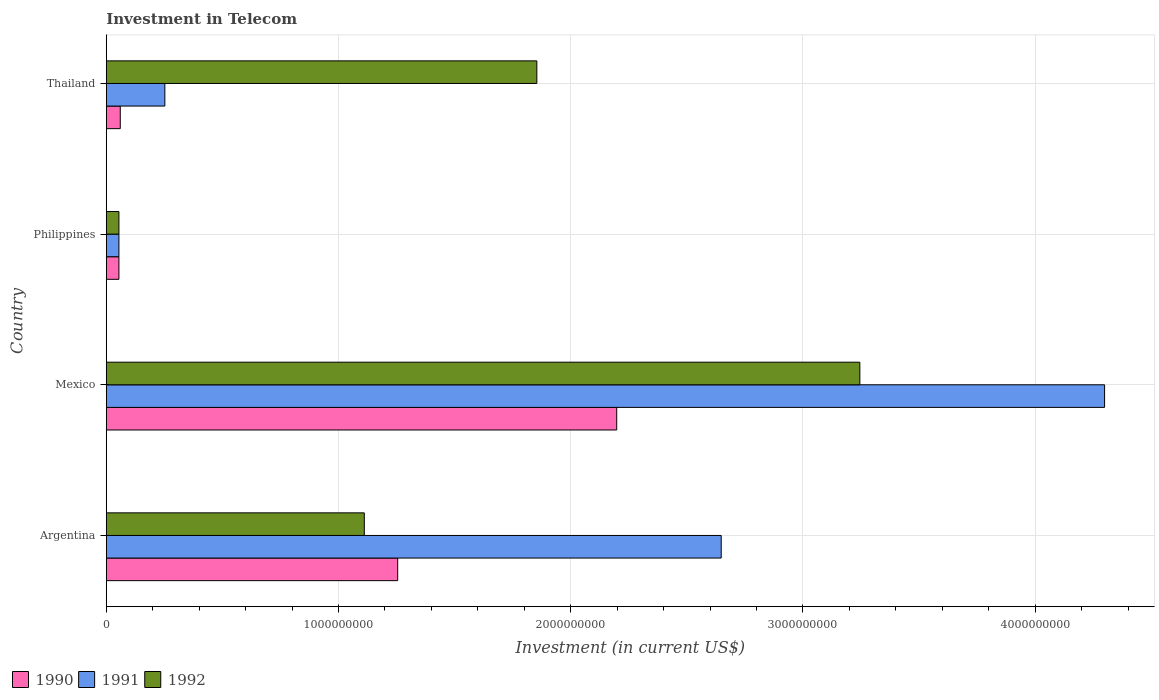How many groups of bars are there?
Provide a short and direct response. 4. How many bars are there on the 2nd tick from the bottom?
Offer a very short reply. 3. What is the amount invested in telecom in 1991 in Mexico?
Keep it short and to the point. 4.30e+09. Across all countries, what is the maximum amount invested in telecom in 1992?
Keep it short and to the point. 3.24e+09. Across all countries, what is the minimum amount invested in telecom in 1991?
Offer a very short reply. 5.42e+07. In which country was the amount invested in telecom in 1990 maximum?
Offer a very short reply. Mexico. What is the total amount invested in telecom in 1990 in the graph?
Provide a succinct answer. 3.57e+09. What is the difference between the amount invested in telecom in 1990 in Mexico and that in Philippines?
Ensure brevity in your answer.  2.14e+09. What is the difference between the amount invested in telecom in 1991 in Philippines and the amount invested in telecom in 1990 in Mexico?
Make the answer very short. -2.14e+09. What is the average amount invested in telecom in 1992 per country?
Keep it short and to the point. 1.57e+09. What is the difference between the amount invested in telecom in 1991 and amount invested in telecom in 1990 in Philippines?
Provide a succinct answer. 0. In how many countries, is the amount invested in telecom in 1992 greater than 800000000 US$?
Provide a succinct answer. 3. What is the ratio of the amount invested in telecom in 1991 in Argentina to that in Thailand?
Keep it short and to the point. 10.51. What is the difference between the highest and the second highest amount invested in telecom in 1991?
Your answer should be very brief. 1.65e+09. What is the difference between the highest and the lowest amount invested in telecom in 1991?
Your answer should be very brief. 4.24e+09. Is the sum of the amount invested in telecom in 1991 in Argentina and Mexico greater than the maximum amount invested in telecom in 1990 across all countries?
Offer a terse response. Yes. What does the 3rd bar from the bottom in Philippines represents?
Your answer should be very brief. 1992. Are all the bars in the graph horizontal?
Give a very brief answer. Yes. How many countries are there in the graph?
Your answer should be compact. 4. What is the difference between two consecutive major ticks on the X-axis?
Provide a short and direct response. 1.00e+09. Does the graph contain grids?
Your answer should be very brief. Yes. Where does the legend appear in the graph?
Provide a short and direct response. Bottom left. How many legend labels are there?
Keep it short and to the point. 3. How are the legend labels stacked?
Offer a terse response. Horizontal. What is the title of the graph?
Give a very brief answer. Investment in Telecom. Does "1974" appear as one of the legend labels in the graph?
Provide a succinct answer. No. What is the label or title of the X-axis?
Your answer should be very brief. Investment (in current US$). What is the label or title of the Y-axis?
Your answer should be very brief. Country. What is the Investment (in current US$) of 1990 in Argentina?
Make the answer very short. 1.25e+09. What is the Investment (in current US$) in 1991 in Argentina?
Make the answer very short. 2.65e+09. What is the Investment (in current US$) of 1992 in Argentina?
Offer a terse response. 1.11e+09. What is the Investment (in current US$) in 1990 in Mexico?
Give a very brief answer. 2.20e+09. What is the Investment (in current US$) of 1991 in Mexico?
Your answer should be compact. 4.30e+09. What is the Investment (in current US$) in 1992 in Mexico?
Ensure brevity in your answer.  3.24e+09. What is the Investment (in current US$) in 1990 in Philippines?
Offer a very short reply. 5.42e+07. What is the Investment (in current US$) in 1991 in Philippines?
Offer a terse response. 5.42e+07. What is the Investment (in current US$) of 1992 in Philippines?
Offer a terse response. 5.42e+07. What is the Investment (in current US$) of 1990 in Thailand?
Keep it short and to the point. 6.00e+07. What is the Investment (in current US$) of 1991 in Thailand?
Provide a succinct answer. 2.52e+08. What is the Investment (in current US$) of 1992 in Thailand?
Keep it short and to the point. 1.85e+09. Across all countries, what is the maximum Investment (in current US$) of 1990?
Your answer should be very brief. 2.20e+09. Across all countries, what is the maximum Investment (in current US$) of 1991?
Your response must be concise. 4.30e+09. Across all countries, what is the maximum Investment (in current US$) in 1992?
Your response must be concise. 3.24e+09. Across all countries, what is the minimum Investment (in current US$) in 1990?
Keep it short and to the point. 5.42e+07. Across all countries, what is the minimum Investment (in current US$) of 1991?
Keep it short and to the point. 5.42e+07. Across all countries, what is the minimum Investment (in current US$) of 1992?
Your answer should be compact. 5.42e+07. What is the total Investment (in current US$) of 1990 in the graph?
Give a very brief answer. 3.57e+09. What is the total Investment (in current US$) of 1991 in the graph?
Ensure brevity in your answer.  7.25e+09. What is the total Investment (in current US$) of 1992 in the graph?
Your response must be concise. 6.26e+09. What is the difference between the Investment (in current US$) in 1990 in Argentina and that in Mexico?
Make the answer very short. -9.43e+08. What is the difference between the Investment (in current US$) in 1991 in Argentina and that in Mexico?
Keep it short and to the point. -1.65e+09. What is the difference between the Investment (in current US$) of 1992 in Argentina and that in Mexico?
Provide a succinct answer. -2.13e+09. What is the difference between the Investment (in current US$) in 1990 in Argentina and that in Philippines?
Keep it short and to the point. 1.20e+09. What is the difference between the Investment (in current US$) in 1991 in Argentina and that in Philippines?
Your response must be concise. 2.59e+09. What is the difference between the Investment (in current US$) in 1992 in Argentina and that in Philippines?
Provide a succinct answer. 1.06e+09. What is the difference between the Investment (in current US$) of 1990 in Argentina and that in Thailand?
Provide a succinct answer. 1.19e+09. What is the difference between the Investment (in current US$) of 1991 in Argentina and that in Thailand?
Provide a short and direct response. 2.40e+09. What is the difference between the Investment (in current US$) of 1992 in Argentina and that in Thailand?
Keep it short and to the point. -7.43e+08. What is the difference between the Investment (in current US$) of 1990 in Mexico and that in Philippines?
Your response must be concise. 2.14e+09. What is the difference between the Investment (in current US$) in 1991 in Mexico and that in Philippines?
Make the answer very short. 4.24e+09. What is the difference between the Investment (in current US$) of 1992 in Mexico and that in Philippines?
Your answer should be very brief. 3.19e+09. What is the difference between the Investment (in current US$) of 1990 in Mexico and that in Thailand?
Provide a short and direct response. 2.14e+09. What is the difference between the Investment (in current US$) of 1991 in Mexico and that in Thailand?
Give a very brief answer. 4.05e+09. What is the difference between the Investment (in current US$) in 1992 in Mexico and that in Thailand?
Your response must be concise. 1.39e+09. What is the difference between the Investment (in current US$) of 1990 in Philippines and that in Thailand?
Make the answer very short. -5.80e+06. What is the difference between the Investment (in current US$) in 1991 in Philippines and that in Thailand?
Offer a very short reply. -1.98e+08. What is the difference between the Investment (in current US$) in 1992 in Philippines and that in Thailand?
Offer a very short reply. -1.80e+09. What is the difference between the Investment (in current US$) in 1990 in Argentina and the Investment (in current US$) in 1991 in Mexico?
Provide a succinct answer. -3.04e+09. What is the difference between the Investment (in current US$) in 1990 in Argentina and the Investment (in current US$) in 1992 in Mexico?
Provide a short and direct response. -1.99e+09. What is the difference between the Investment (in current US$) of 1991 in Argentina and the Investment (in current US$) of 1992 in Mexico?
Your answer should be very brief. -5.97e+08. What is the difference between the Investment (in current US$) of 1990 in Argentina and the Investment (in current US$) of 1991 in Philippines?
Your answer should be compact. 1.20e+09. What is the difference between the Investment (in current US$) in 1990 in Argentina and the Investment (in current US$) in 1992 in Philippines?
Provide a succinct answer. 1.20e+09. What is the difference between the Investment (in current US$) in 1991 in Argentina and the Investment (in current US$) in 1992 in Philippines?
Provide a succinct answer. 2.59e+09. What is the difference between the Investment (in current US$) of 1990 in Argentina and the Investment (in current US$) of 1991 in Thailand?
Ensure brevity in your answer.  1.00e+09. What is the difference between the Investment (in current US$) of 1990 in Argentina and the Investment (in current US$) of 1992 in Thailand?
Your answer should be very brief. -5.99e+08. What is the difference between the Investment (in current US$) of 1991 in Argentina and the Investment (in current US$) of 1992 in Thailand?
Your response must be concise. 7.94e+08. What is the difference between the Investment (in current US$) in 1990 in Mexico and the Investment (in current US$) in 1991 in Philippines?
Offer a very short reply. 2.14e+09. What is the difference between the Investment (in current US$) of 1990 in Mexico and the Investment (in current US$) of 1992 in Philippines?
Provide a succinct answer. 2.14e+09. What is the difference between the Investment (in current US$) of 1991 in Mexico and the Investment (in current US$) of 1992 in Philippines?
Your answer should be compact. 4.24e+09. What is the difference between the Investment (in current US$) in 1990 in Mexico and the Investment (in current US$) in 1991 in Thailand?
Give a very brief answer. 1.95e+09. What is the difference between the Investment (in current US$) in 1990 in Mexico and the Investment (in current US$) in 1992 in Thailand?
Keep it short and to the point. 3.44e+08. What is the difference between the Investment (in current US$) in 1991 in Mexico and the Investment (in current US$) in 1992 in Thailand?
Keep it short and to the point. 2.44e+09. What is the difference between the Investment (in current US$) of 1990 in Philippines and the Investment (in current US$) of 1991 in Thailand?
Your answer should be compact. -1.98e+08. What is the difference between the Investment (in current US$) of 1990 in Philippines and the Investment (in current US$) of 1992 in Thailand?
Give a very brief answer. -1.80e+09. What is the difference between the Investment (in current US$) in 1991 in Philippines and the Investment (in current US$) in 1992 in Thailand?
Provide a succinct answer. -1.80e+09. What is the average Investment (in current US$) in 1990 per country?
Provide a short and direct response. 8.92e+08. What is the average Investment (in current US$) in 1991 per country?
Ensure brevity in your answer.  1.81e+09. What is the average Investment (in current US$) of 1992 per country?
Provide a short and direct response. 1.57e+09. What is the difference between the Investment (in current US$) in 1990 and Investment (in current US$) in 1991 in Argentina?
Make the answer very short. -1.39e+09. What is the difference between the Investment (in current US$) of 1990 and Investment (in current US$) of 1992 in Argentina?
Ensure brevity in your answer.  1.44e+08. What is the difference between the Investment (in current US$) of 1991 and Investment (in current US$) of 1992 in Argentina?
Your answer should be very brief. 1.54e+09. What is the difference between the Investment (in current US$) of 1990 and Investment (in current US$) of 1991 in Mexico?
Ensure brevity in your answer.  -2.10e+09. What is the difference between the Investment (in current US$) in 1990 and Investment (in current US$) in 1992 in Mexico?
Your answer should be compact. -1.05e+09. What is the difference between the Investment (in current US$) of 1991 and Investment (in current US$) of 1992 in Mexico?
Ensure brevity in your answer.  1.05e+09. What is the difference between the Investment (in current US$) of 1990 and Investment (in current US$) of 1991 in Philippines?
Provide a short and direct response. 0. What is the difference between the Investment (in current US$) in 1990 and Investment (in current US$) in 1992 in Philippines?
Your answer should be very brief. 0. What is the difference between the Investment (in current US$) in 1991 and Investment (in current US$) in 1992 in Philippines?
Provide a succinct answer. 0. What is the difference between the Investment (in current US$) of 1990 and Investment (in current US$) of 1991 in Thailand?
Keep it short and to the point. -1.92e+08. What is the difference between the Investment (in current US$) in 1990 and Investment (in current US$) in 1992 in Thailand?
Give a very brief answer. -1.79e+09. What is the difference between the Investment (in current US$) in 1991 and Investment (in current US$) in 1992 in Thailand?
Provide a succinct answer. -1.60e+09. What is the ratio of the Investment (in current US$) in 1990 in Argentina to that in Mexico?
Give a very brief answer. 0.57. What is the ratio of the Investment (in current US$) of 1991 in Argentina to that in Mexico?
Your response must be concise. 0.62. What is the ratio of the Investment (in current US$) in 1992 in Argentina to that in Mexico?
Offer a very short reply. 0.34. What is the ratio of the Investment (in current US$) of 1990 in Argentina to that in Philippines?
Keep it short and to the point. 23.15. What is the ratio of the Investment (in current US$) of 1991 in Argentina to that in Philippines?
Your answer should be very brief. 48.86. What is the ratio of the Investment (in current US$) of 1992 in Argentina to that in Philippines?
Offer a terse response. 20.5. What is the ratio of the Investment (in current US$) in 1990 in Argentina to that in Thailand?
Keep it short and to the point. 20.91. What is the ratio of the Investment (in current US$) of 1991 in Argentina to that in Thailand?
Your response must be concise. 10.51. What is the ratio of the Investment (in current US$) in 1992 in Argentina to that in Thailand?
Offer a very short reply. 0.6. What is the ratio of the Investment (in current US$) in 1990 in Mexico to that in Philippines?
Your answer should be very brief. 40.55. What is the ratio of the Investment (in current US$) in 1991 in Mexico to that in Philippines?
Offer a terse response. 79.32. What is the ratio of the Investment (in current US$) in 1992 in Mexico to that in Philippines?
Offer a very short reply. 59.87. What is the ratio of the Investment (in current US$) in 1990 in Mexico to that in Thailand?
Make the answer very short. 36.63. What is the ratio of the Investment (in current US$) in 1991 in Mexico to that in Thailand?
Your answer should be compact. 17.06. What is the ratio of the Investment (in current US$) of 1992 in Mexico to that in Thailand?
Your answer should be very brief. 1.75. What is the ratio of the Investment (in current US$) in 1990 in Philippines to that in Thailand?
Give a very brief answer. 0.9. What is the ratio of the Investment (in current US$) of 1991 in Philippines to that in Thailand?
Provide a succinct answer. 0.22. What is the ratio of the Investment (in current US$) in 1992 in Philippines to that in Thailand?
Your response must be concise. 0.03. What is the difference between the highest and the second highest Investment (in current US$) in 1990?
Make the answer very short. 9.43e+08. What is the difference between the highest and the second highest Investment (in current US$) of 1991?
Give a very brief answer. 1.65e+09. What is the difference between the highest and the second highest Investment (in current US$) of 1992?
Your response must be concise. 1.39e+09. What is the difference between the highest and the lowest Investment (in current US$) of 1990?
Provide a succinct answer. 2.14e+09. What is the difference between the highest and the lowest Investment (in current US$) of 1991?
Your response must be concise. 4.24e+09. What is the difference between the highest and the lowest Investment (in current US$) in 1992?
Ensure brevity in your answer.  3.19e+09. 